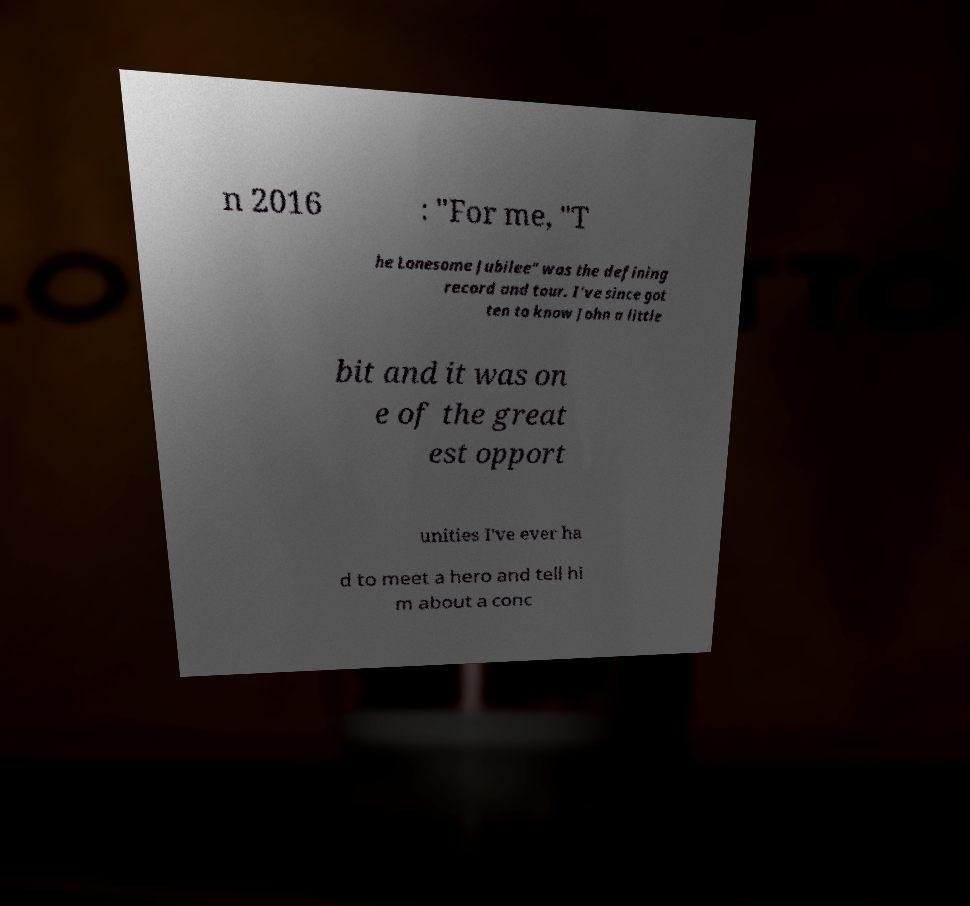I need the written content from this picture converted into text. Can you do that? n 2016 : "For me, "T he Lonesome Jubilee" was the defining record and tour. I've since got ten to know John a little bit and it was on e of the great est opport unities I've ever ha d to meet a hero and tell hi m about a conc 